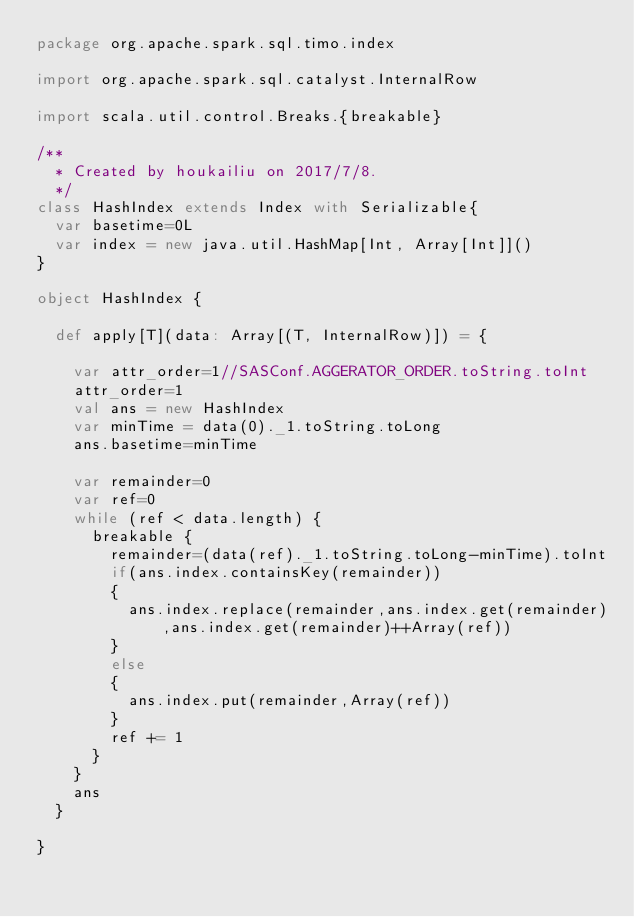<code> <loc_0><loc_0><loc_500><loc_500><_Scala_>package org.apache.spark.sql.timo.index

import org.apache.spark.sql.catalyst.InternalRow

import scala.util.control.Breaks.{breakable}

/**
  * Created by houkailiu on 2017/7/8.
  */
class HashIndex extends Index with Serializable{
  var basetime=0L
  var index = new java.util.HashMap[Int, Array[Int]]()
}

object HashIndex {

  def apply[T](data: Array[(T, InternalRow)]) = {

    var attr_order=1//SASConf.AGGERATOR_ORDER.toString.toInt
    attr_order=1
    val ans = new HashIndex
    var minTime = data(0)._1.toString.toLong
    ans.basetime=minTime

    var remainder=0
    var ref=0
    while (ref < data.length) {
      breakable {
        remainder=(data(ref)._1.toString.toLong-minTime).toInt
        if(ans.index.containsKey(remainder))
        {
          ans.index.replace(remainder,ans.index.get(remainder),ans.index.get(remainder)++Array(ref))
        }
        else
        {
          ans.index.put(remainder,Array(ref))
        }
        ref += 1
      }
    }
    ans
  }

}</code> 